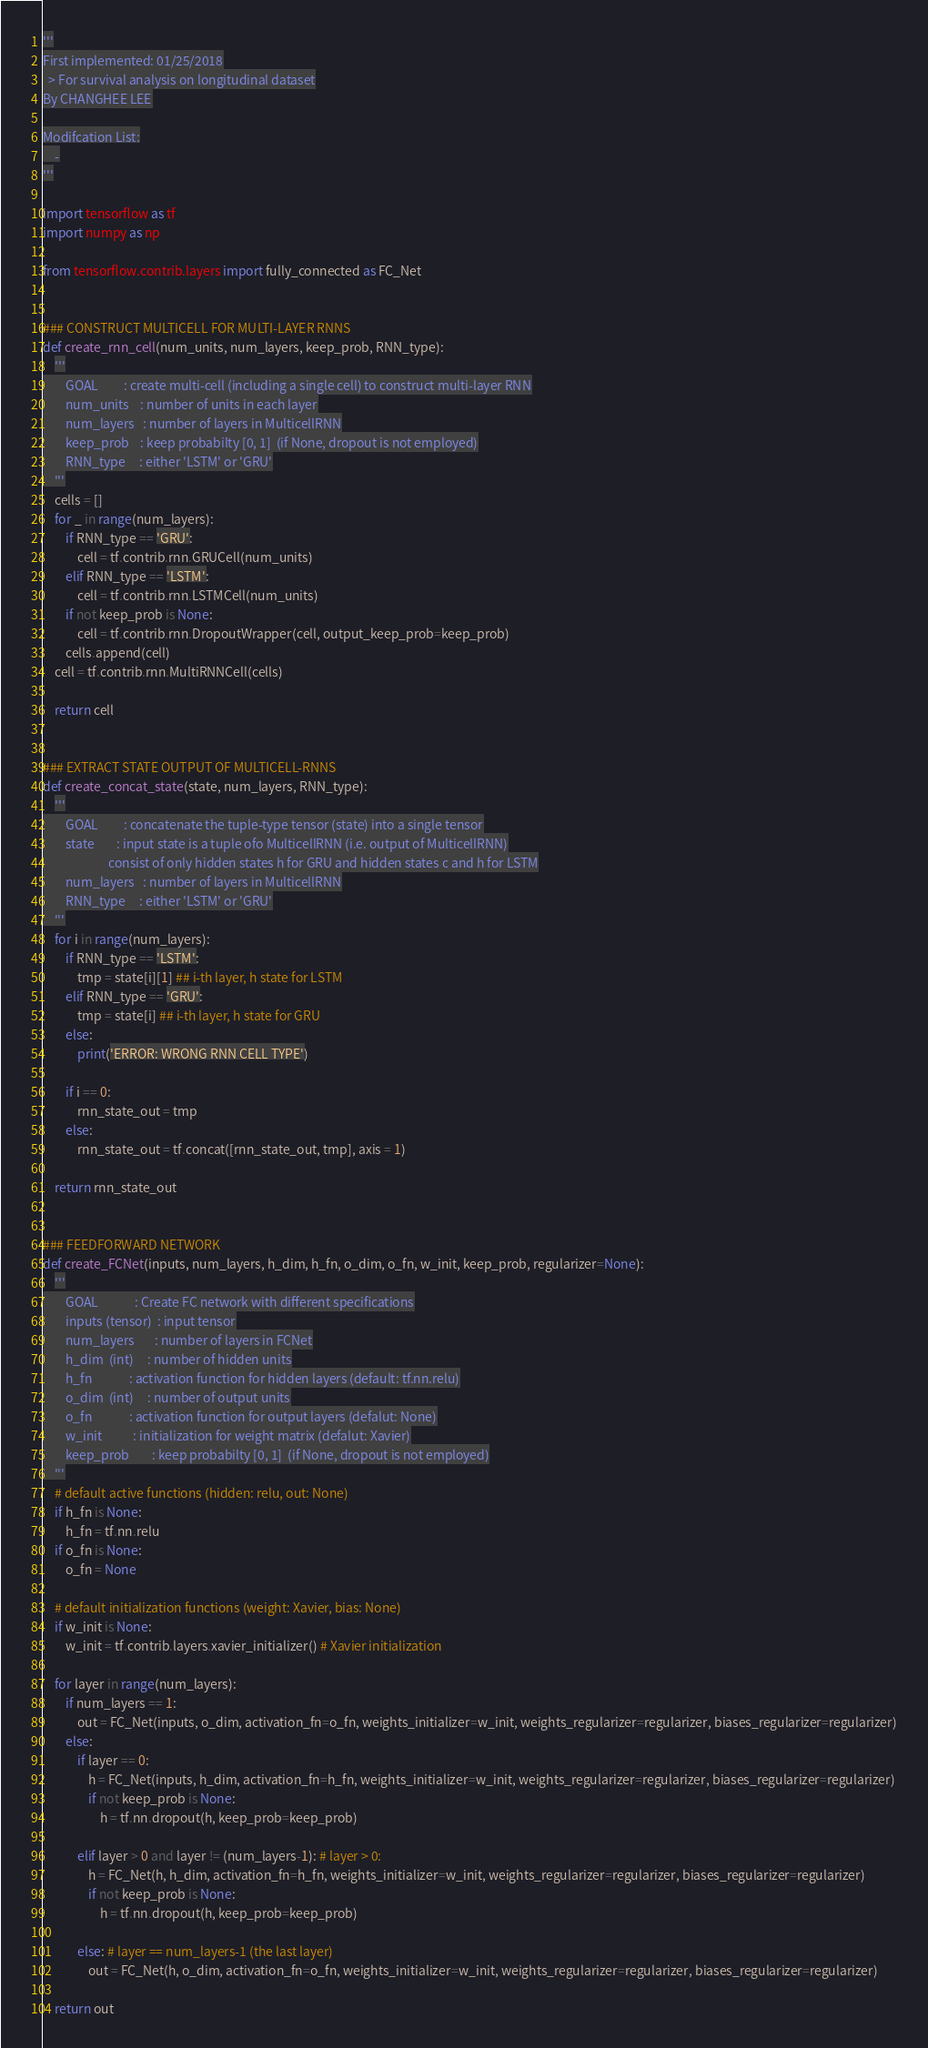<code> <loc_0><loc_0><loc_500><loc_500><_Python_>'''
First implemented: 01/25/2018
  > For survival analysis on longitudinal dataset
By CHANGHEE LEE

Modifcation List:
	-
'''

import tensorflow as tf
import numpy as np

from tensorflow.contrib.layers import fully_connected as FC_Net


### CONSTRUCT MULTICELL FOR MULTI-LAYER RNNS
def create_rnn_cell(num_units, num_layers, keep_prob, RNN_type):
    '''
        GOAL         : create multi-cell (including a single cell) to construct multi-layer RNN
        num_units    : number of units in each layer
        num_layers   : number of layers in MulticellRNN
        keep_prob    : keep probabilty [0, 1]  (if None, dropout is not employed)
        RNN_type     : either 'LSTM' or 'GRU'
    '''
    cells = []
    for _ in range(num_layers):
        if RNN_type == 'GRU':
            cell = tf.contrib.rnn.GRUCell(num_units)
        elif RNN_type == 'LSTM':
            cell = tf.contrib.rnn.LSTMCell(num_units)
        if not keep_prob is None:
            cell = tf.contrib.rnn.DropoutWrapper(cell, output_keep_prob=keep_prob)
        cells.append(cell)
    cell = tf.contrib.rnn.MultiRNNCell(cells)

    return cell


### EXTRACT STATE OUTPUT OF MULTICELL-RNNS
def create_concat_state(state, num_layers, RNN_type):
    '''
        GOAL	     : concatenate the tuple-type tensor (state) into a single tensor
        state        : input state is a tuple ofo MulticellRNN (i.e. output of MulticellRNN)
                       consist of only hidden states h for GRU and hidden states c and h for LSTM
        num_layers   : number of layers in MulticellRNN
        RNN_type     : either 'LSTM' or 'GRU'
    '''
    for i in range(num_layers):
        if RNN_type == 'LSTM':
            tmp = state[i][1] ## i-th layer, h state for LSTM
        elif RNN_type == 'GRU':
            tmp = state[i] ## i-th layer, h state for GRU
        else:
            print('ERROR: WRONG RNN CELL TYPE')

        if i == 0:
            rnn_state_out = tmp
        else:
            rnn_state_out = tf.concat([rnn_state_out, tmp], axis = 1)

    return rnn_state_out


### FEEDFORWARD NETWORK
def create_FCNet(inputs, num_layers, h_dim, h_fn, o_dim, o_fn, w_init, keep_prob, regularizer=None):
    '''
        GOAL             : Create FC network with different specifications
        inputs (tensor)  : input tensor
        num_layers       : number of layers in FCNet
        h_dim  (int)     : number of hidden units
        h_fn             : activation function for hidden layers (default: tf.nn.relu)
        o_dim  (int)     : number of output units
        o_fn             : activation function for output layers (defalut: None)
        w_init           : initialization for weight matrix (defalut: Xavier)
        keep_prob        : keep probabilty [0, 1]  (if None, dropout is not employed)
    '''
    # default active functions (hidden: relu, out: None)
    if h_fn is None:
        h_fn = tf.nn.relu
    if o_fn is None:
        o_fn = None

    # default initialization functions (weight: Xavier, bias: None)
    if w_init is None:
        w_init = tf.contrib.layers.xavier_initializer() # Xavier initialization

    for layer in range(num_layers):
        if num_layers == 1:
            out = FC_Net(inputs, o_dim, activation_fn=o_fn, weights_initializer=w_init, weights_regularizer=regularizer, biases_regularizer=regularizer)
        else:
            if layer == 0:
                h = FC_Net(inputs, h_dim, activation_fn=h_fn, weights_initializer=w_init, weights_regularizer=regularizer, biases_regularizer=regularizer)
                if not keep_prob is None:
                    h = tf.nn.dropout(h, keep_prob=keep_prob)

            elif layer > 0 and layer != (num_layers-1): # layer > 0:
                h = FC_Net(h, h_dim, activation_fn=h_fn, weights_initializer=w_init, weights_regularizer=regularizer, biases_regularizer=regularizer)
                if not keep_prob is None:
                    h = tf.nn.dropout(h, keep_prob=keep_prob)

            else: # layer == num_layers-1 (the last layer)
                out = FC_Net(h, o_dim, activation_fn=o_fn, weights_initializer=w_init, weights_regularizer=regularizer, biases_regularizer=regularizer)

    return out
</code> 